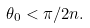<formula> <loc_0><loc_0><loc_500><loc_500>\theta _ { 0 } < \pi / 2 n .</formula> 